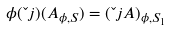Convert formula to latex. <formula><loc_0><loc_0><loc_500><loc_500>\phi ( \L { j } ) ( A _ { \phi , S } ) = ( \L { j } A ) _ { \phi , S _ { 1 } }</formula> 